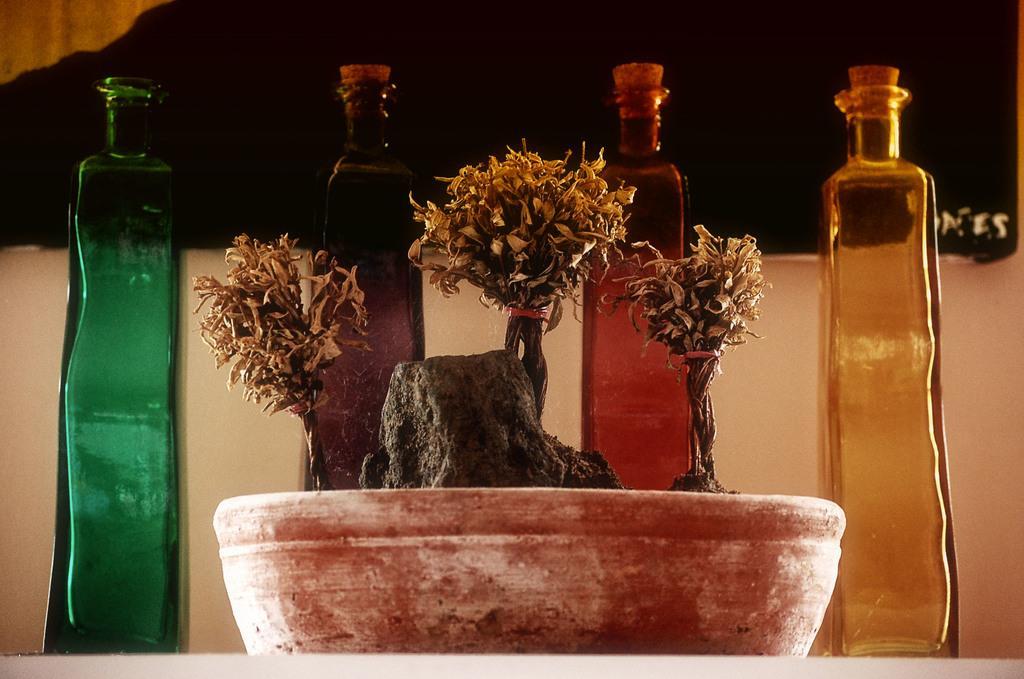Describe this image in one or two sentences. In this image i can see a pot at the background i can see four bottles and a wall. 